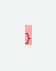<code> <loc_0><loc_0><loc_500><loc_500><_CSS_>}</code> 